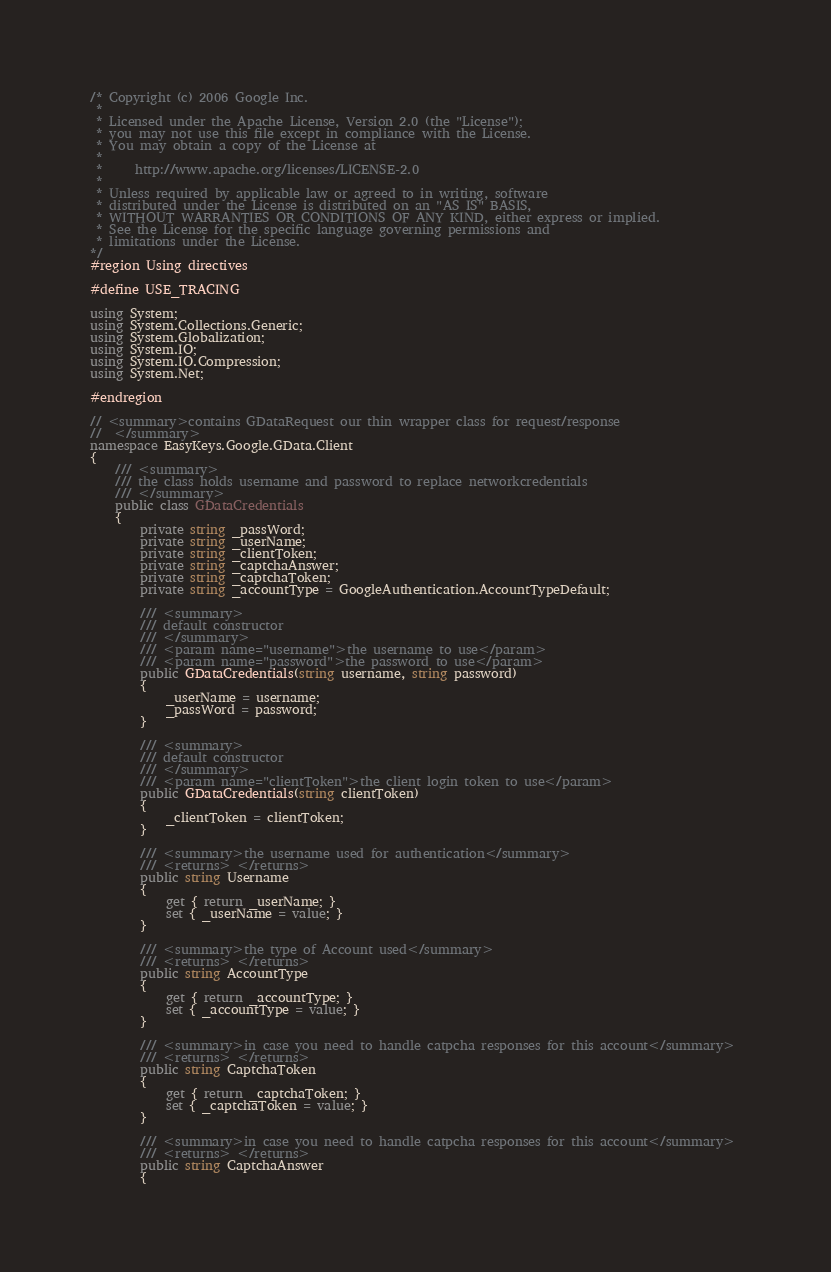Convert code to text. <code><loc_0><loc_0><loc_500><loc_500><_C#_>/* Copyright (c) 2006 Google Inc.
 *
 * Licensed under the Apache License, Version 2.0 (the "License");
 * you may not use this file except in compliance with the License.
 * You may obtain a copy of the License at
 *
 *     http://www.apache.org/licenses/LICENSE-2.0
 *
 * Unless required by applicable law or agreed to in writing, software
 * distributed under the License is distributed on an "AS IS" BASIS,
 * WITHOUT WARRANTIES OR CONDITIONS OF ANY KIND, either express or implied.
 * See the License for the specific language governing permissions and
 * limitations under the License.
*/
#region Using directives

#define USE_TRACING

using System;
using System.Collections.Generic;
using System.Globalization;
using System.IO;
using System.IO.Compression;
using System.Net;

#endregion

// <summary>contains GDataRequest our thin wrapper class for request/response
//  </summary>
namespace EasyKeys.Google.GData.Client
{
    /// <summary>
    /// the class holds username and password to replace networkcredentials
    /// </summary>
    public class GDataCredentials
    {
        private string _passWord;
        private string _userName;
        private string _clientToken;
        private string _captchaAnswer;
        private string _captchaToken;
        private string _accountType = GoogleAuthentication.AccountTypeDefault;

        /// <summary>
        /// default constructor
        /// </summary>
        /// <param name="username">the username to use</param>
        /// <param name="password">the password to use</param>
        public GDataCredentials(string username, string password)
        {
            _userName = username;
            _passWord = password;
        }

        /// <summary>
        /// default constructor
        /// </summary>
        /// <param name="clientToken">the client login token to use</param>
        public GDataCredentials(string clientToken)
        {
            _clientToken = clientToken;
        }

        /// <summary>the username used for authentication</summary> 
        /// <returns> </returns>
        public string Username
        {
            get { return _userName; }
            set { _userName = value; }
        }

        /// <summary>the type of Account used</summary> 
        /// <returns> </returns>
        public string AccountType
        {
            get { return _accountType; }
            set { _accountType = value; }
        }

        /// <summary>in case you need to handle catpcha responses for this account</summary> 
        /// <returns> </returns>
        public string CaptchaToken
        {
            get { return _captchaToken; }
            set { _captchaToken = value; }
        }

        /// <summary>in case you need to handle catpcha responses for this account</summary> 
        /// <returns> </returns>
        public string CaptchaAnswer
        {</code> 